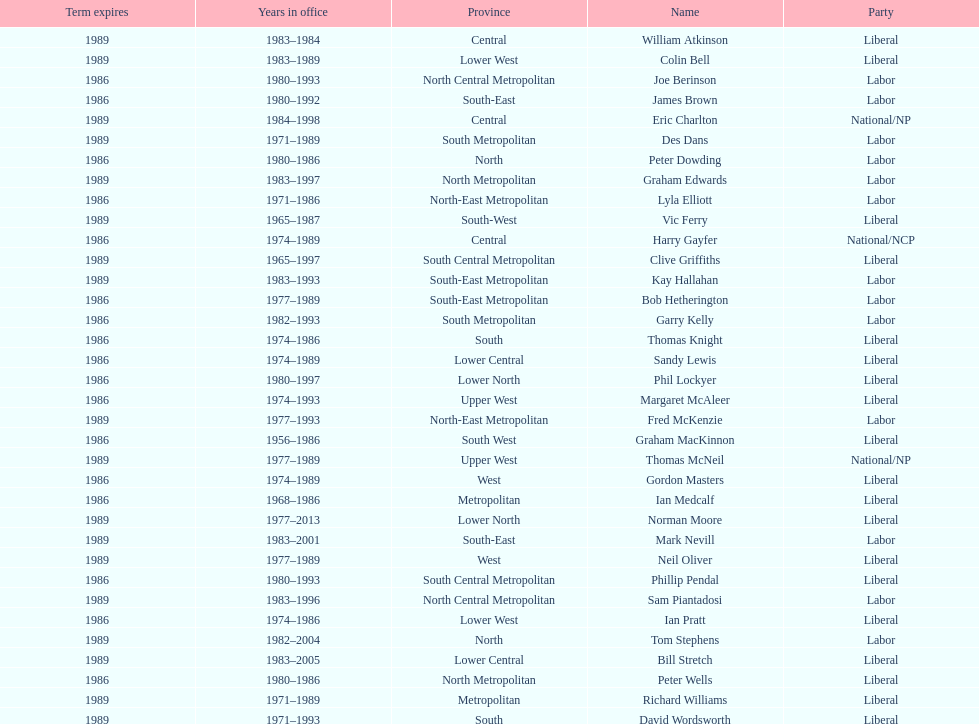Parse the table in full. {'header': ['Term expires', 'Years in office', 'Province', 'Name', 'Party'], 'rows': [['1989', '1983–1984', 'Central', 'William Atkinson', 'Liberal'], ['1989', '1983–1989', 'Lower West', 'Colin Bell', 'Liberal'], ['1986', '1980–1993', 'North Central Metropolitan', 'Joe Berinson', 'Labor'], ['1986', '1980–1992', 'South-East', 'James Brown', 'Labor'], ['1989', '1984–1998', 'Central', 'Eric Charlton', 'National/NP'], ['1989', '1971–1989', 'South Metropolitan', 'Des Dans', 'Labor'], ['1986', '1980–1986', 'North', 'Peter Dowding', 'Labor'], ['1989', '1983–1997', 'North Metropolitan', 'Graham Edwards', 'Labor'], ['1986', '1971–1986', 'North-East Metropolitan', 'Lyla Elliott', 'Labor'], ['1989', '1965–1987', 'South-West', 'Vic Ferry', 'Liberal'], ['1986', '1974–1989', 'Central', 'Harry Gayfer', 'National/NCP'], ['1989', '1965–1997', 'South Central Metropolitan', 'Clive Griffiths', 'Liberal'], ['1989', '1983–1993', 'South-East Metropolitan', 'Kay Hallahan', 'Labor'], ['1986', '1977–1989', 'South-East Metropolitan', 'Bob Hetherington', 'Labor'], ['1986', '1982–1993', 'South Metropolitan', 'Garry Kelly', 'Labor'], ['1986', '1974–1986', 'South', 'Thomas Knight', 'Liberal'], ['1986', '1974–1989', 'Lower Central', 'Sandy Lewis', 'Liberal'], ['1986', '1980–1997', 'Lower North', 'Phil Lockyer', 'Liberal'], ['1986', '1974–1993', 'Upper West', 'Margaret McAleer', 'Liberal'], ['1989', '1977–1993', 'North-East Metropolitan', 'Fred McKenzie', 'Labor'], ['1986', '1956–1986', 'South West', 'Graham MacKinnon', 'Liberal'], ['1989', '1977–1989', 'Upper West', 'Thomas McNeil', 'National/NP'], ['1986', '1974–1989', 'West', 'Gordon Masters', 'Liberal'], ['1986', '1968–1986', 'Metropolitan', 'Ian Medcalf', 'Liberal'], ['1989', '1977–2013', 'Lower North', 'Norman Moore', 'Liberal'], ['1989', '1983–2001', 'South-East', 'Mark Nevill', 'Labor'], ['1989', '1977–1989', 'West', 'Neil Oliver', 'Liberal'], ['1986', '1980–1993', 'South Central Metropolitan', 'Phillip Pendal', 'Liberal'], ['1989', '1983–1996', 'North Central Metropolitan', 'Sam Piantadosi', 'Labor'], ['1986', '1974–1986', 'Lower West', 'Ian Pratt', 'Liberal'], ['1989', '1982–2004', 'North', 'Tom Stephens', 'Labor'], ['1989', '1983–2005', 'Lower Central', 'Bill Stretch', 'Liberal'], ['1986', '1980–1986', 'North Metropolitan', 'Peter Wells', 'Liberal'], ['1989', '1971–1989', 'Metropolitan', 'Richard Williams', 'Liberal'], ['1989', '1971–1993', 'South', 'David Wordsworth', 'Liberal']]} What is the total number of members whose term expires in 1989? 9. 